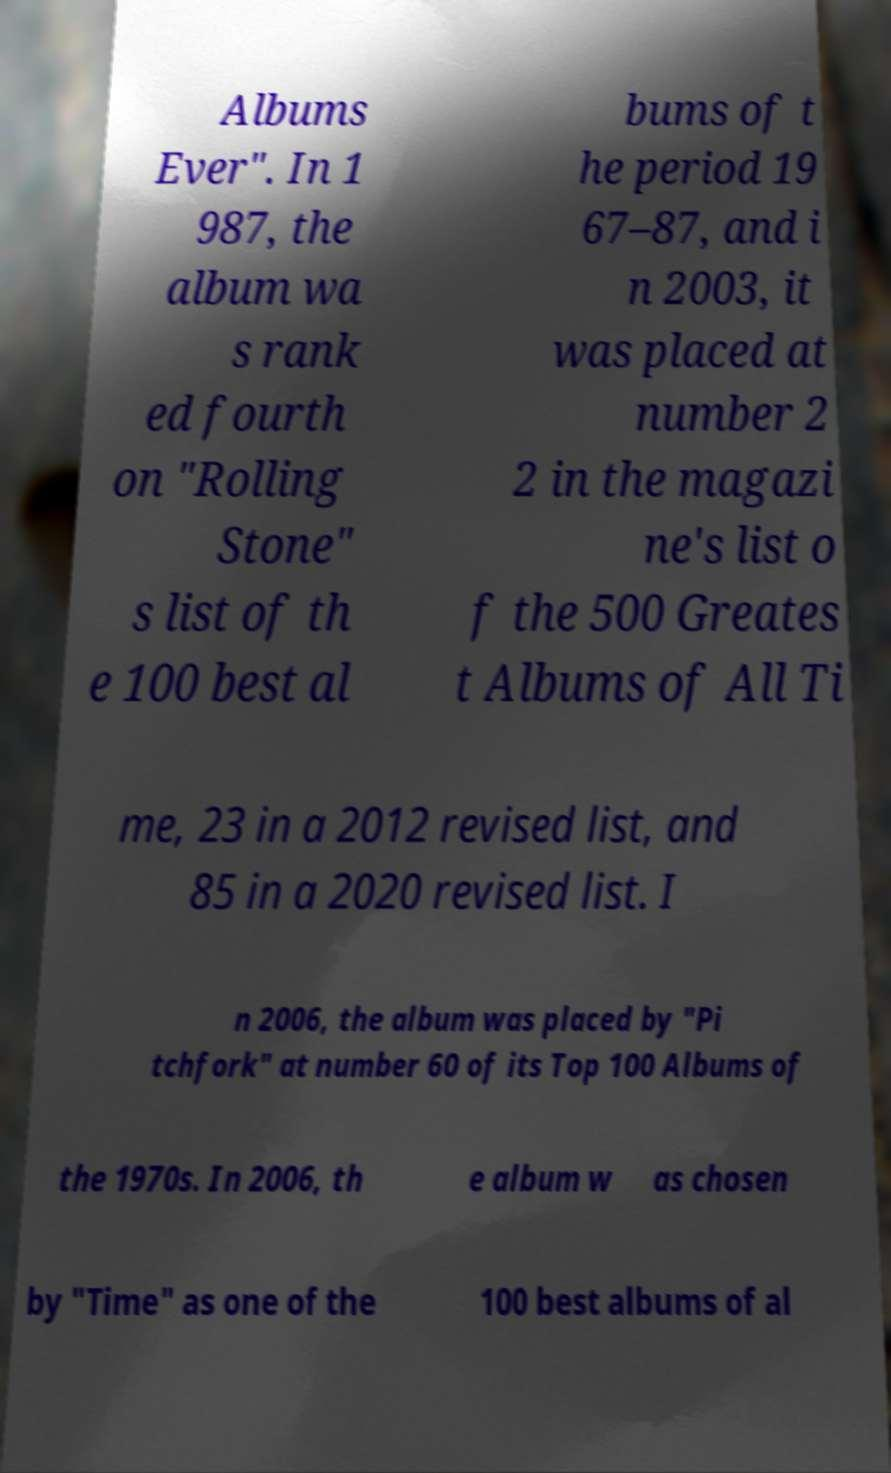There's text embedded in this image that I need extracted. Can you transcribe it verbatim? Albums Ever". In 1 987, the album wa s rank ed fourth on "Rolling Stone" s list of th e 100 best al bums of t he period 19 67–87, and i n 2003, it was placed at number 2 2 in the magazi ne's list o f the 500 Greates t Albums of All Ti me, 23 in a 2012 revised list, and 85 in a 2020 revised list. I n 2006, the album was placed by "Pi tchfork" at number 60 of its Top 100 Albums of the 1970s. In 2006, th e album w as chosen by "Time" as one of the 100 best albums of al 